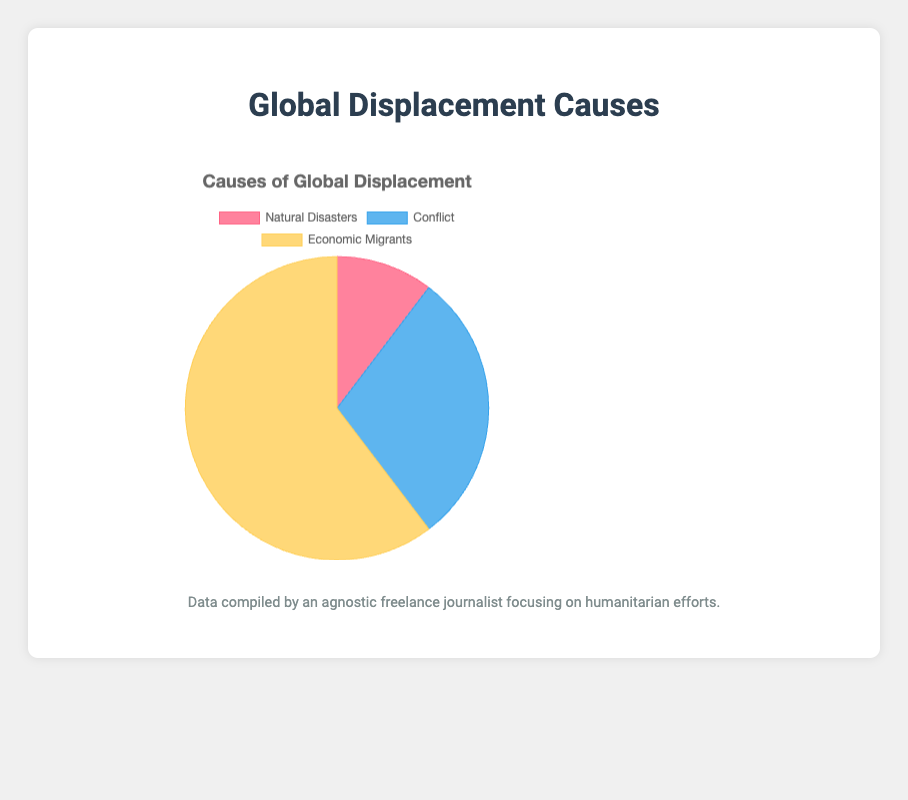What percentage of total displacement is due to natural disasters? The figure shows three categories: Natural Disasters, Conflict, and Economic Migrants with respective displacements of 3,600,000, 10,200,000, and 21,000,000. To calculate the percentage for natural disasters, use the formula: (Displacement by Natural Disasters / Total Displacement) * 100. So, (3,600,000 / (3,600,000 + 10,200,000 + 21,000,000)) * 100 ≈ 9.2%.
Answer: Approximately 9.2% Which cause of displacement has the highest number of displaced people? The categories in the figure are Natural Disasters (3,600,000), Conflict (10,200,000), and Economic Migrants (21,000,000). Comparing these values, Economic Migrants have the highest displacement count.
Answer: Economic Migrants If combined, do the displacements caused by Natural Disasters and Conflict surpass those caused by Economic Migrants? Natural Disasters and Conflict have displacements of 3,600,000 and 10,200,000 respectively. Their combined displacement is 3,600,000 + 10,200,000 = 13,800,000. Comparing this with Economic Migrants (21,000,000), 13,800,000 is less than 21,000,000.
Answer: No What is the color representing the conflict-related displacement in the pie chart? According to the provided color scheme, Conflict-related displacement is shown with a shade of blue.
Answer: Blue How much greater is the displacement caused by Economic Migrants compared to Conflict? The figure shows displacements for Economic Migrants (21,000,000) and Conflict (10,200,000). The difference is 21,000,000 - 10,200,000 = 11,000,000.
Answer: 11,000,000 Which cause has the smallest proportion of the total displacement? The proportions are derived from the displacements of Natural Disasters (3,600,000), Conflict (10,200,000), and Economic Migrants (21,000,000). Natural Disasters have the smallest displacement value, hence the smallest proportion.
Answer: Natural Disasters How does the displacement due to the South Sudan Conflict compare to the total displacement from Natural Disasters? The South Sudan Conflict displacement is 2,500,000, while the total for Natural Disasters is 3,600,000. Comparing these values, 2,500,000 is less than 3,600,000.
Answer: Less What is the difference in displacement between the largest natural disaster event and the smallest conflict event? The largest natural disaster displacement is 1,300,000 (2010 Haiti Earthquake), and the smallest conflict displacement is 900,000 (Rohingya Crisis). The difference is 1,300,000 - 900,000 = 400,000.
Answer: 400,000 Does the figure indicate that displacements due to economic reasons are visually more prominent than other causes? The largest segment in the pie chart corresponds to Economic Migrants, visually indicated by the yellow color occupying the most space. This suggests prominence.
Answer: Yes 